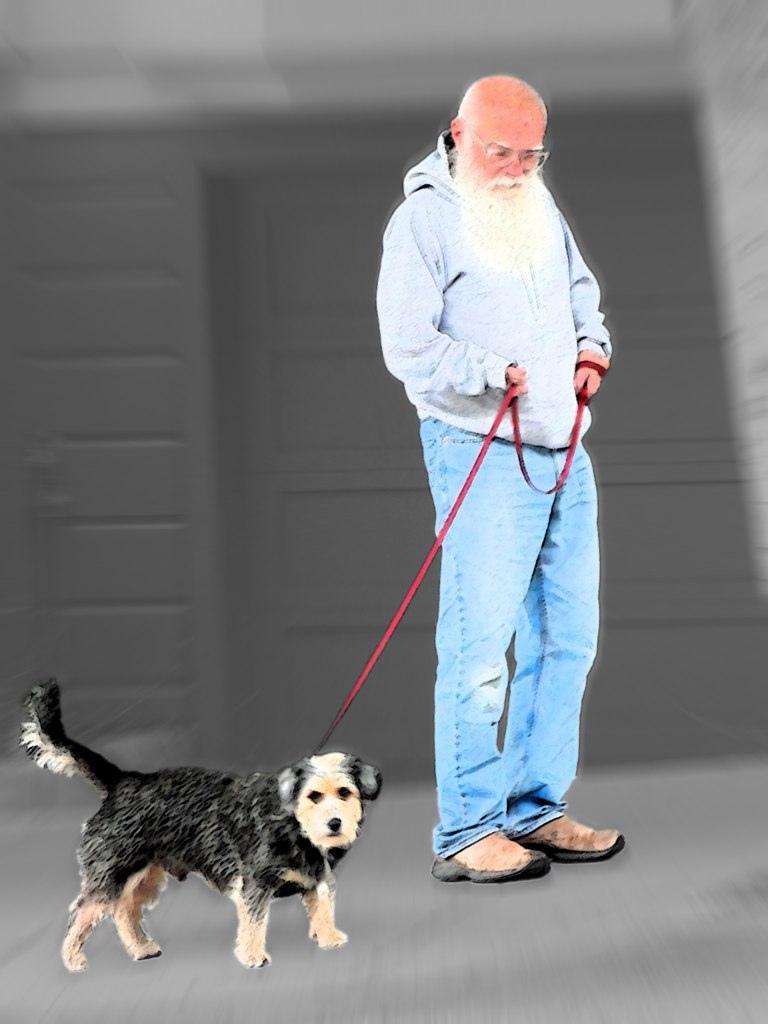Describe this image in one or two sentences. In the middle of the picture, man in grey jacket is holding the rope of a dog. Beside him, we see a black dog. Behind this, behind the man, we see a wall which is grey in color. 